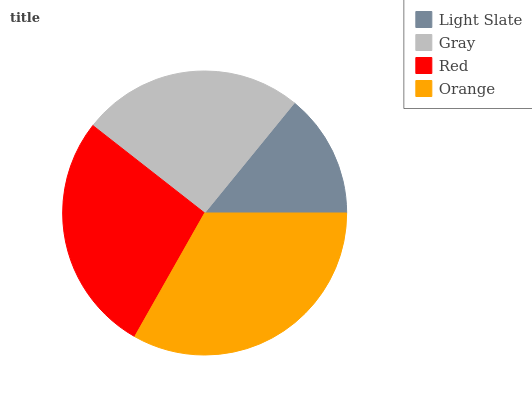Is Light Slate the minimum?
Answer yes or no. Yes. Is Orange the maximum?
Answer yes or no. Yes. Is Gray the minimum?
Answer yes or no. No. Is Gray the maximum?
Answer yes or no. No. Is Gray greater than Light Slate?
Answer yes or no. Yes. Is Light Slate less than Gray?
Answer yes or no. Yes. Is Light Slate greater than Gray?
Answer yes or no. No. Is Gray less than Light Slate?
Answer yes or no. No. Is Red the high median?
Answer yes or no. Yes. Is Gray the low median?
Answer yes or no. Yes. Is Orange the high median?
Answer yes or no. No. Is Orange the low median?
Answer yes or no. No. 